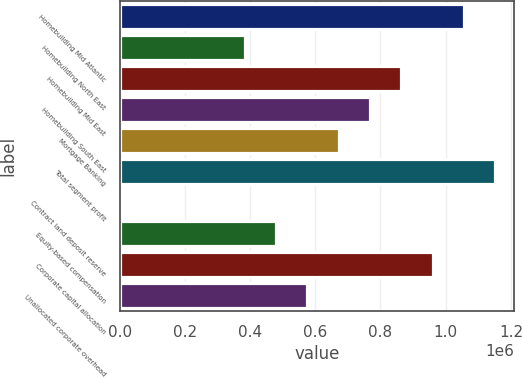Convert chart to OTSL. <chart><loc_0><loc_0><loc_500><loc_500><bar_chart><fcel>Homebuilding Mid Atlantic<fcel>Homebuilding North East<fcel>Homebuilding Mid East<fcel>Homebuilding South East<fcel>Mortgage Banking<fcel>Total segment profit<fcel>Contract land deposit reserve<fcel>Equity-based compensation<fcel>Corporate capital allocation<fcel>Unallocated corporate overhead<nl><fcel>1.05563e+06<fcel>384363<fcel>863837<fcel>767942<fcel>672047<fcel>1.15152e+06<fcel>783<fcel>480258<fcel>959732<fcel>576152<nl></chart> 